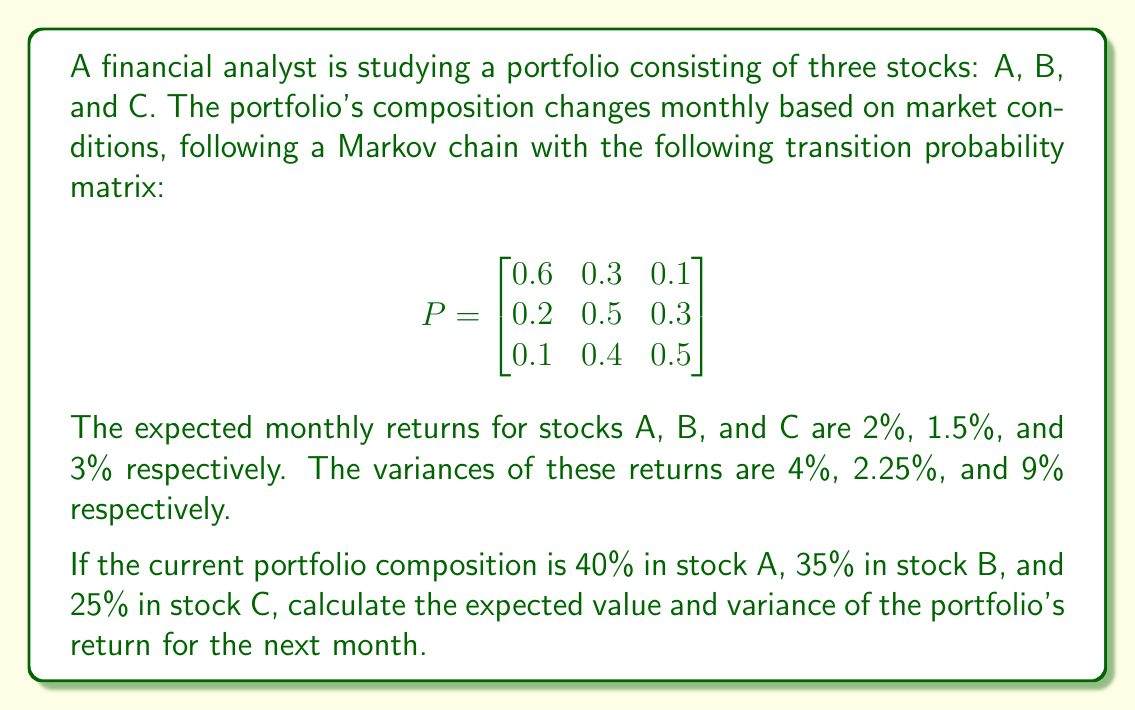Help me with this question. Let's approach this step-by-step:

1) First, we need to calculate the expected portfolio composition for the next month. We can do this by multiplying the current composition vector with the transition probability matrix:

   $$\begin{bmatrix}0.4 & 0.35 & 0.25\end{bmatrix} \times \begin{bmatrix}
   0.6 & 0.3 & 0.1 \\
   0.2 & 0.5 & 0.3 \\
   0.1 & 0.4 & 0.5
   \end{bmatrix} = \begin{bmatrix}0.355 & 0.39 & 0.255\end{bmatrix}$$

2) Now, we can calculate the expected return of the portfolio:

   $E[R] = 0.355 \times 2\% + 0.39 \times 1.5\% + 0.255 \times 3\% = 2.09\%$

3) To calculate the variance, we need to use the formula:
   
   $Var(R) = \sum_{i=1}^n w_i^2 \sigma_i^2 + \sum_{i=1}^n \sum_{j\neq i} w_i w_j \sigma_i \sigma_j \rho_{ij}$

   where $w_i$ are the weights, $\sigma_i^2$ are the variances, and $\rho_{ij}$ are the correlations between assets.

4) Assuming the returns are uncorrelated (as correlation information is not provided), we can simplify this to:

   $Var(R) = \sum_{i=1}^n w_i^2 \sigma_i^2$

5) Plugging in the values:

   $Var(R) = 0.355^2 \times 4\% + 0.39^2 \times 2.25\% + 0.255^2 \times 9\%$
   
   $= 0.126025 \times 4\% + 0.1521 \times 2.25\% + 0.065025 \times 9\%$
   
   $= 0.00504\% + 0.00342\% + 0.00585\%$
   
   $= 0.01431\%$

Therefore, the expected return is 2.09% and the variance is 0.01431%.
Answer: Expected return: 2.09%, Variance: 0.01431% 